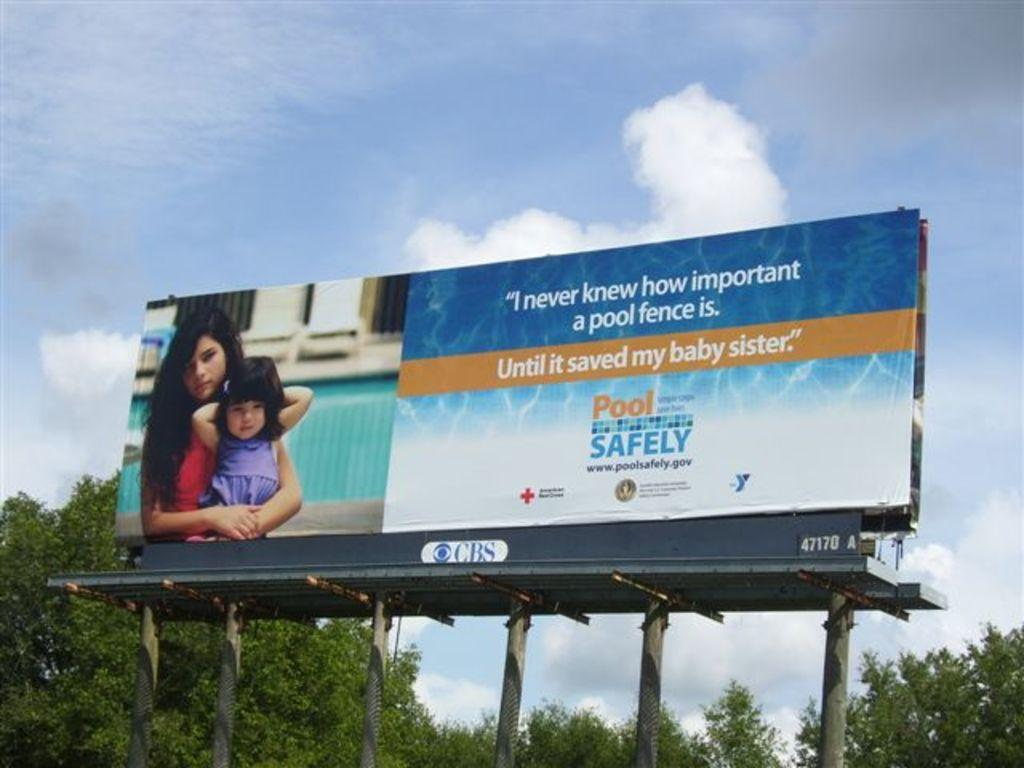<image>
Share a concise interpretation of the image provided. A CBS advertisement for pool fences that say it's the best way to own a pool safely. 